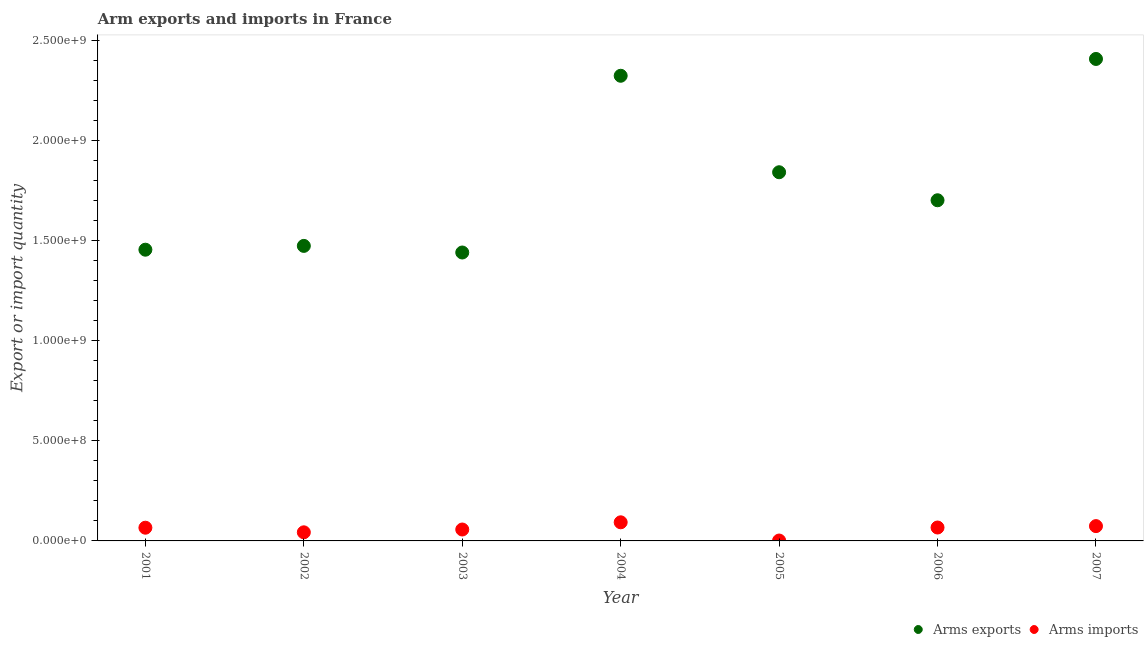How many different coloured dotlines are there?
Ensure brevity in your answer.  2. Is the number of dotlines equal to the number of legend labels?
Provide a succinct answer. Yes. What is the arms exports in 2003?
Ensure brevity in your answer.  1.44e+09. Across all years, what is the maximum arms imports?
Provide a short and direct response. 9.30e+07. Across all years, what is the minimum arms imports?
Keep it short and to the point. 2.00e+06. In which year was the arms imports minimum?
Offer a terse response. 2005. What is the total arms exports in the graph?
Offer a very short reply. 1.26e+1. What is the difference between the arms imports in 2002 and that in 2004?
Offer a terse response. -5.00e+07. What is the difference between the arms exports in 2001 and the arms imports in 2004?
Give a very brief answer. 1.36e+09. What is the average arms imports per year?
Give a very brief answer. 5.74e+07. In the year 2001, what is the difference between the arms imports and arms exports?
Your response must be concise. -1.39e+09. What is the ratio of the arms exports in 2004 to that in 2005?
Offer a terse response. 1.26. Is the arms imports in 2003 less than that in 2006?
Ensure brevity in your answer.  Yes. Is the difference between the arms exports in 2006 and 2007 greater than the difference between the arms imports in 2006 and 2007?
Give a very brief answer. No. What is the difference between the highest and the second highest arms imports?
Provide a short and direct response. 1.90e+07. What is the difference between the highest and the lowest arms imports?
Make the answer very short. 9.10e+07. In how many years, is the arms exports greater than the average arms exports taken over all years?
Your response must be concise. 3. Is the arms exports strictly greater than the arms imports over the years?
Offer a very short reply. Yes. How many dotlines are there?
Offer a very short reply. 2. What is the difference between two consecutive major ticks on the Y-axis?
Ensure brevity in your answer.  5.00e+08. Does the graph contain any zero values?
Your answer should be compact. No. Does the graph contain grids?
Provide a short and direct response. No. How many legend labels are there?
Your answer should be very brief. 2. What is the title of the graph?
Keep it short and to the point. Arm exports and imports in France. Does "Agricultural land" appear as one of the legend labels in the graph?
Offer a very short reply. No. What is the label or title of the Y-axis?
Provide a succinct answer. Export or import quantity. What is the Export or import quantity of Arms exports in 2001?
Provide a succinct answer. 1.46e+09. What is the Export or import quantity in Arms imports in 2001?
Make the answer very short. 6.60e+07. What is the Export or import quantity of Arms exports in 2002?
Provide a short and direct response. 1.47e+09. What is the Export or import quantity of Arms imports in 2002?
Make the answer very short. 4.30e+07. What is the Export or import quantity of Arms exports in 2003?
Your answer should be very brief. 1.44e+09. What is the Export or import quantity in Arms imports in 2003?
Offer a terse response. 5.70e+07. What is the Export or import quantity in Arms exports in 2004?
Your answer should be very brief. 2.32e+09. What is the Export or import quantity of Arms imports in 2004?
Offer a very short reply. 9.30e+07. What is the Export or import quantity of Arms exports in 2005?
Make the answer very short. 1.84e+09. What is the Export or import quantity in Arms imports in 2005?
Provide a succinct answer. 2.00e+06. What is the Export or import quantity of Arms exports in 2006?
Make the answer very short. 1.70e+09. What is the Export or import quantity of Arms imports in 2006?
Ensure brevity in your answer.  6.70e+07. What is the Export or import quantity in Arms exports in 2007?
Offer a very short reply. 2.41e+09. What is the Export or import quantity of Arms imports in 2007?
Provide a succinct answer. 7.40e+07. Across all years, what is the maximum Export or import quantity of Arms exports?
Ensure brevity in your answer.  2.41e+09. Across all years, what is the maximum Export or import quantity of Arms imports?
Your answer should be very brief. 9.30e+07. Across all years, what is the minimum Export or import quantity in Arms exports?
Keep it short and to the point. 1.44e+09. What is the total Export or import quantity in Arms exports in the graph?
Ensure brevity in your answer.  1.26e+1. What is the total Export or import quantity in Arms imports in the graph?
Your answer should be compact. 4.02e+08. What is the difference between the Export or import quantity of Arms exports in 2001 and that in 2002?
Keep it short and to the point. -1.90e+07. What is the difference between the Export or import quantity of Arms imports in 2001 and that in 2002?
Your answer should be very brief. 2.30e+07. What is the difference between the Export or import quantity in Arms exports in 2001 and that in 2003?
Give a very brief answer. 1.40e+07. What is the difference between the Export or import quantity in Arms imports in 2001 and that in 2003?
Provide a short and direct response. 9.00e+06. What is the difference between the Export or import quantity in Arms exports in 2001 and that in 2004?
Your answer should be very brief. -8.69e+08. What is the difference between the Export or import quantity in Arms imports in 2001 and that in 2004?
Ensure brevity in your answer.  -2.70e+07. What is the difference between the Export or import quantity of Arms exports in 2001 and that in 2005?
Provide a succinct answer. -3.87e+08. What is the difference between the Export or import quantity of Arms imports in 2001 and that in 2005?
Provide a short and direct response. 6.40e+07. What is the difference between the Export or import quantity in Arms exports in 2001 and that in 2006?
Keep it short and to the point. -2.47e+08. What is the difference between the Export or import quantity in Arms exports in 2001 and that in 2007?
Offer a terse response. -9.53e+08. What is the difference between the Export or import quantity of Arms imports in 2001 and that in 2007?
Your answer should be compact. -8.00e+06. What is the difference between the Export or import quantity of Arms exports in 2002 and that in 2003?
Make the answer very short. 3.30e+07. What is the difference between the Export or import quantity of Arms imports in 2002 and that in 2003?
Your answer should be compact. -1.40e+07. What is the difference between the Export or import quantity of Arms exports in 2002 and that in 2004?
Offer a very short reply. -8.50e+08. What is the difference between the Export or import quantity in Arms imports in 2002 and that in 2004?
Your answer should be very brief. -5.00e+07. What is the difference between the Export or import quantity in Arms exports in 2002 and that in 2005?
Ensure brevity in your answer.  -3.68e+08. What is the difference between the Export or import quantity of Arms imports in 2002 and that in 2005?
Make the answer very short. 4.10e+07. What is the difference between the Export or import quantity of Arms exports in 2002 and that in 2006?
Offer a very short reply. -2.28e+08. What is the difference between the Export or import quantity in Arms imports in 2002 and that in 2006?
Make the answer very short. -2.40e+07. What is the difference between the Export or import quantity of Arms exports in 2002 and that in 2007?
Your response must be concise. -9.34e+08. What is the difference between the Export or import quantity in Arms imports in 2002 and that in 2007?
Your answer should be compact. -3.10e+07. What is the difference between the Export or import quantity of Arms exports in 2003 and that in 2004?
Your response must be concise. -8.83e+08. What is the difference between the Export or import quantity of Arms imports in 2003 and that in 2004?
Keep it short and to the point. -3.60e+07. What is the difference between the Export or import quantity of Arms exports in 2003 and that in 2005?
Give a very brief answer. -4.01e+08. What is the difference between the Export or import quantity of Arms imports in 2003 and that in 2005?
Ensure brevity in your answer.  5.50e+07. What is the difference between the Export or import quantity of Arms exports in 2003 and that in 2006?
Give a very brief answer. -2.61e+08. What is the difference between the Export or import quantity of Arms imports in 2003 and that in 2006?
Ensure brevity in your answer.  -1.00e+07. What is the difference between the Export or import quantity of Arms exports in 2003 and that in 2007?
Offer a terse response. -9.67e+08. What is the difference between the Export or import quantity of Arms imports in 2003 and that in 2007?
Give a very brief answer. -1.70e+07. What is the difference between the Export or import quantity in Arms exports in 2004 and that in 2005?
Offer a terse response. 4.82e+08. What is the difference between the Export or import quantity in Arms imports in 2004 and that in 2005?
Make the answer very short. 9.10e+07. What is the difference between the Export or import quantity of Arms exports in 2004 and that in 2006?
Your answer should be very brief. 6.22e+08. What is the difference between the Export or import quantity in Arms imports in 2004 and that in 2006?
Your answer should be compact. 2.60e+07. What is the difference between the Export or import quantity in Arms exports in 2004 and that in 2007?
Ensure brevity in your answer.  -8.40e+07. What is the difference between the Export or import quantity of Arms imports in 2004 and that in 2007?
Your answer should be compact. 1.90e+07. What is the difference between the Export or import quantity in Arms exports in 2005 and that in 2006?
Ensure brevity in your answer.  1.40e+08. What is the difference between the Export or import quantity in Arms imports in 2005 and that in 2006?
Provide a short and direct response. -6.50e+07. What is the difference between the Export or import quantity in Arms exports in 2005 and that in 2007?
Provide a succinct answer. -5.66e+08. What is the difference between the Export or import quantity in Arms imports in 2005 and that in 2007?
Ensure brevity in your answer.  -7.20e+07. What is the difference between the Export or import quantity of Arms exports in 2006 and that in 2007?
Offer a very short reply. -7.06e+08. What is the difference between the Export or import quantity in Arms imports in 2006 and that in 2007?
Your answer should be compact. -7.00e+06. What is the difference between the Export or import quantity in Arms exports in 2001 and the Export or import quantity in Arms imports in 2002?
Provide a succinct answer. 1.41e+09. What is the difference between the Export or import quantity of Arms exports in 2001 and the Export or import quantity of Arms imports in 2003?
Ensure brevity in your answer.  1.40e+09. What is the difference between the Export or import quantity of Arms exports in 2001 and the Export or import quantity of Arms imports in 2004?
Your answer should be very brief. 1.36e+09. What is the difference between the Export or import quantity in Arms exports in 2001 and the Export or import quantity in Arms imports in 2005?
Give a very brief answer. 1.45e+09. What is the difference between the Export or import quantity in Arms exports in 2001 and the Export or import quantity in Arms imports in 2006?
Your answer should be very brief. 1.39e+09. What is the difference between the Export or import quantity of Arms exports in 2001 and the Export or import quantity of Arms imports in 2007?
Offer a terse response. 1.38e+09. What is the difference between the Export or import quantity of Arms exports in 2002 and the Export or import quantity of Arms imports in 2003?
Provide a succinct answer. 1.42e+09. What is the difference between the Export or import quantity of Arms exports in 2002 and the Export or import quantity of Arms imports in 2004?
Provide a succinct answer. 1.38e+09. What is the difference between the Export or import quantity of Arms exports in 2002 and the Export or import quantity of Arms imports in 2005?
Your answer should be compact. 1.47e+09. What is the difference between the Export or import quantity in Arms exports in 2002 and the Export or import quantity in Arms imports in 2006?
Your answer should be compact. 1.41e+09. What is the difference between the Export or import quantity of Arms exports in 2002 and the Export or import quantity of Arms imports in 2007?
Provide a short and direct response. 1.40e+09. What is the difference between the Export or import quantity in Arms exports in 2003 and the Export or import quantity in Arms imports in 2004?
Your response must be concise. 1.35e+09. What is the difference between the Export or import quantity of Arms exports in 2003 and the Export or import quantity of Arms imports in 2005?
Offer a very short reply. 1.44e+09. What is the difference between the Export or import quantity in Arms exports in 2003 and the Export or import quantity in Arms imports in 2006?
Give a very brief answer. 1.37e+09. What is the difference between the Export or import quantity of Arms exports in 2003 and the Export or import quantity of Arms imports in 2007?
Keep it short and to the point. 1.37e+09. What is the difference between the Export or import quantity of Arms exports in 2004 and the Export or import quantity of Arms imports in 2005?
Ensure brevity in your answer.  2.32e+09. What is the difference between the Export or import quantity in Arms exports in 2004 and the Export or import quantity in Arms imports in 2006?
Your answer should be compact. 2.26e+09. What is the difference between the Export or import quantity in Arms exports in 2004 and the Export or import quantity in Arms imports in 2007?
Offer a very short reply. 2.25e+09. What is the difference between the Export or import quantity in Arms exports in 2005 and the Export or import quantity in Arms imports in 2006?
Your answer should be very brief. 1.78e+09. What is the difference between the Export or import quantity in Arms exports in 2005 and the Export or import quantity in Arms imports in 2007?
Keep it short and to the point. 1.77e+09. What is the difference between the Export or import quantity of Arms exports in 2006 and the Export or import quantity of Arms imports in 2007?
Offer a terse response. 1.63e+09. What is the average Export or import quantity of Arms exports per year?
Make the answer very short. 1.81e+09. What is the average Export or import quantity of Arms imports per year?
Offer a terse response. 5.74e+07. In the year 2001, what is the difference between the Export or import quantity in Arms exports and Export or import quantity in Arms imports?
Offer a terse response. 1.39e+09. In the year 2002, what is the difference between the Export or import quantity of Arms exports and Export or import quantity of Arms imports?
Your response must be concise. 1.43e+09. In the year 2003, what is the difference between the Export or import quantity in Arms exports and Export or import quantity in Arms imports?
Offer a terse response. 1.38e+09. In the year 2004, what is the difference between the Export or import quantity of Arms exports and Export or import quantity of Arms imports?
Provide a short and direct response. 2.23e+09. In the year 2005, what is the difference between the Export or import quantity in Arms exports and Export or import quantity in Arms imports?
Offer a terse response. 1.84e+09. In the year 2006, what is the difference between the Export or import quantity in Arms exports and Export or import quantity in Arms imports?
Provide a short and direct response. 1.64e+09. In the year 2007, what is the difference between the Export or import quantity in Arms exports and Export or import quantity in Arms imports?
Offer a very short reply. 2.33e+09. What is the ratio of the Export or import quantity of Arms exports in 2001 to that in 2002?
Make the answer very short. 0.99. What is the ratio of the Export or import quantity of Arms imports in 2001 to that in 2002?
Provide a short and direct response. 1.53. What is the ratio of the Export or import quantity of Arms exports in 2001 to that in 2003?
Give a very brief answer. 1.01. What is the ratio of the Export or import quantity of Arms imports in 2001 to that in 2003?
Offer a very short reply. 1.16. What is the ratio of the Export or import quantity in Arms exports in 2001 to that in 2004?
Your answer should be very brief. 0.63. What is the ratio of the Export or import quantity in Arms imports in 2001 to that in 2004?
Your answer should be very brief. 0.71. What is the ratio of the Export or import quantity of Arms exports in 2001 to that in 2005?
Offer a terse response. 0.79. What is the ratio of the Export or import quantity in Arms exports in 2001 to that in 2006?
Your answer should be very brief. 0.85. What is the ratio of the Export or import quantity of Arms imports in 2001 to that in 2006?
Keep it short and to the point. 0.99. What is the ratio of the Export or import quantity in Arms exports in 2001 to that in 2007?
Give a very brief answer. 0.6. What is the ratio of the Export or import quantity of Arms imports in 2001 to that in 2007?
Keep it short and to the point. 0.89. What is the ratio of the Export or import quantity of Arms exports in 2002 to that in 2003?
Keep it short and to the point. 1.02. What is the ratio of the Export or import quantity of Arms imports in 2002 to that in 2003?
Offer a terse response. 0.75. What is the ratio of the Export or import quantity in Arms exports in 2002 to that in 2004?
Give a very brief answer. 0.63. What is the ratio of the Export or import quantity of Arms imports in 2002 to that in 2004?
Your answer should be compact. 0.46. What is the ratio of the Export or import quantity in Arms exports in 2002 to that in 2005?
Your response must be concise. 0.8. What is the ratio of the Export or import quantity in Arms exports in 2002 to that in 2006?
Ensure brevity in your answer.  0.87. What is the ratio of the Export or import quantity of Arms imports in 2002 to that in 2006?
Provide a short and direct response. 0.64. What is the ratio of the Export or import quantity of Arms exports in 2002 to that in 2007?
Give a very brief answer. 0.61. What is the ratio of the Export or import quantity of Arms imports in 2002 to that in 2007?
Offer a very short reply. 0.58. What is the ratio of the Export or import quantity of Arms exports in 2003 to that in 2004?
Ensure brevity in your answer.  0.62. What is the ratio of the Export or import quantity of Arms imports in 2003 to that in 2004?
Make the answer very short. 0.61. What is the ratio of the Export or import quantity in Arms exports in 2003 to that in 2005?
Your answer should be very brief. 0.78. What is the ratio of the Export or import quantity in Arms exports in 2003 to that in 2006?
Keep it short and to the point. 0.85. What is the ratio of the Export or import quantity in Arms imports in 2003 to that in 2006?
Provide a succinct answer. 0.85. What is the ratio of the Export or import quantity of Arms exports in 2003 to that in 2007?
Make the answer very short. 0.6. What is the ratio of the Export or import quantity of Arms imports in 2003 to that in 2007?
Your answer should be very brief. 0.77. What is the ratio of the Export or import quantity in Arms exports in 2004 to that in 2005?
Provide a short and direct response. 1.26. What is the ratio of the Export or import quantity in Arms imports in 2004 to that in 2005?
Provide a short and direct response. 46.5. What is the ratio of the Export or import quantity in Arms exports in 2004 to that in 2006?
Your response must be concise. 1.37. What is the ratio of the Export or import quantity in Arms imports in 2004 to that in 2006?
Your response must be concise. 1.39. What is the ratio of the Export or import quantity of Arms exports in 2004 to that in 2007?
Give a very brief answer. 0.97. What is the ratio of the Export or import quantity in Arms imports in 2004 to that in 2007?
Offer a terse response. 1.26. What is the ratio of the Export or import quantity in Arms exports in 2005 to that in 2006?
Make the answer very short. 1.08. What is the ratio of the Export or import quantity of Arms imports in 2005 to that in 2006?
Keep it short and to the point. 0.03. What is the ratio of the Export or import quantity of Arms exports in 2005 to that in 2007?
Offer a terse response. 0.77. What is the ratio of the Export or import quantity of Arms imports in 2005 to that in 2007?
Give a very brief answer. 0.03. What is the ratio of the Export or import quantity in Arms exports in 2006 to that in 2007?
Provide a short and direct response. 0.71. What is the ratio of the Export or import quantity in Arms imports in 2006 to that in 2007?
Provide a succinct answer. 0.91. What is the difference between the highest and the second highest Export or import quantity in Arms exports?
Provide a succinct answer. 8.40e+07. What is the difference between the highest and the second highest Export or import quantity in Arms imports?
Ensure brevity in your answer.  1.90e+07. What is the difference between the highest and the lowest Export or import quantity in Arms exports?
Provide a short and direct response. 9.67e+08. What is the difference between the highest and the lowest Export or import quantity of Arms imports?
Make the answer very short. 9.10e+07. 